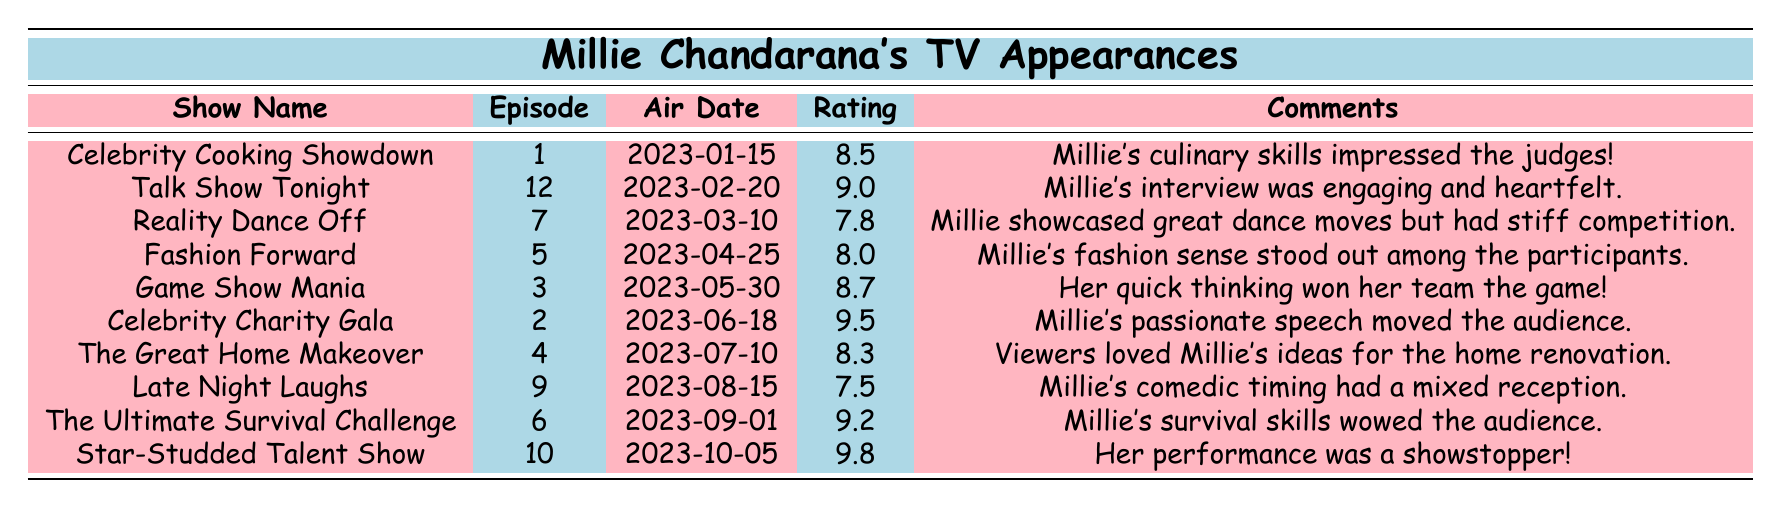What is the viewer rating for the "Celebrity Cooking Showdown"? The viewer rating is listed directly in the corresponding row for that show. It is 8.5.
Answer: 8.5 Which show received the highest viewer rating? By examining the ratings in the table, "Star-Studded Talent Show" has the highest rating of 9.8.
Answer: Star-Studded Talent Show What was Millie's viewer rating in "Late Night Laughs"? The viewer rating for "Late Night Laughs" can be found in that row, which states it is 7.5.
Answer: 7.5 What is the average viewer rating of the shows Millie appeared in? First, total all viewer ratings: (8.5 + 9.0 + 7.8 + 8.0 + 8.7 + 9.5 + 8.3 + 7.5 + 9.2 + 9.8) = 88.3. There are 10 shows, so the average is 88.3 / 10 = 8.83.
Answer: 8.83 Did Millie receive a viewer rating above 9.0 in any of her shows? Examining the viewer ratings, "Celebrity Charity Gala" (9.5), "The Ultimate Survival Challenge" (9.2), and "Star-Studded Talent Show" (9.8) all exceed 9.0.
Answer: Yes How many shows did Millie receive a rating of 8.0 or higher? Count the ratings that are 8.0 or above: Celebrity Cooking Showdown (8.5), Talk Show Tonight (9.0), Fashion Forward (8.0), Game Show Mania (8.7), Celebrity Charity Gala (9.5), The Great Home Makeover (8.3), The Ultimate Survival Challenge (9.2), Star-Studded Talent Show (9.8), totaling 8 shows.
Answer: 8 Which show had the lowest viewer rating, and what was it? Checking the ratings, "Late Night Laughs" has the lowest rating of 7.5.
Answer: Late Night Laughs, 7.5 Was Millie's performance in "Reality Dance Off" rated higher than any of her other appearances? The rating for "Reality Dance Off" is 7.8, which is lower than several other shows, so it wasn't the highest. The highest ratings (9.8, 9.5) exceed that.
Answer: No What comment was provided for "Game Show Mania"? The comment associated with "Game Show Mania" states, "Her quick thinking won her team the game!" This information can be found in the table directly.
Answer: Her quick thinking won her team the game! 